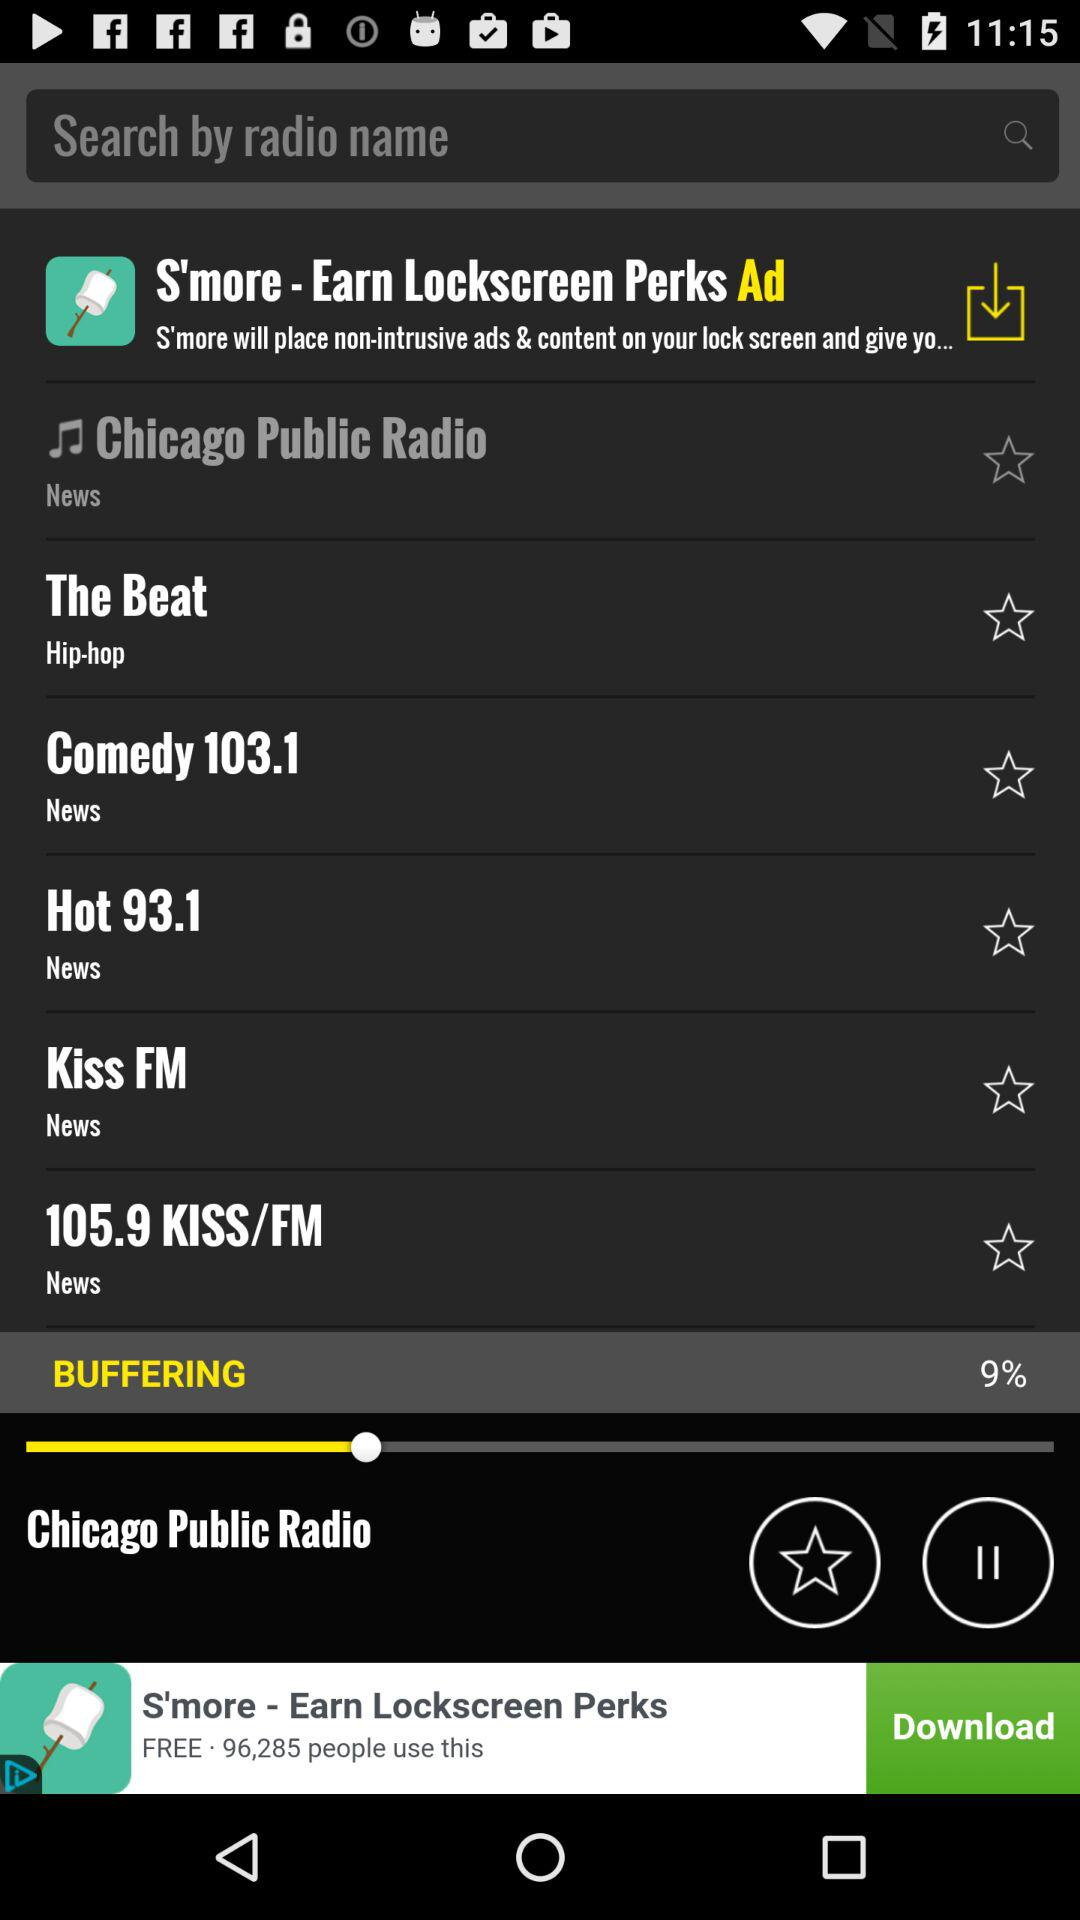Which radio is currently playing? The currently playing radio is "Chicago Public Radio". 